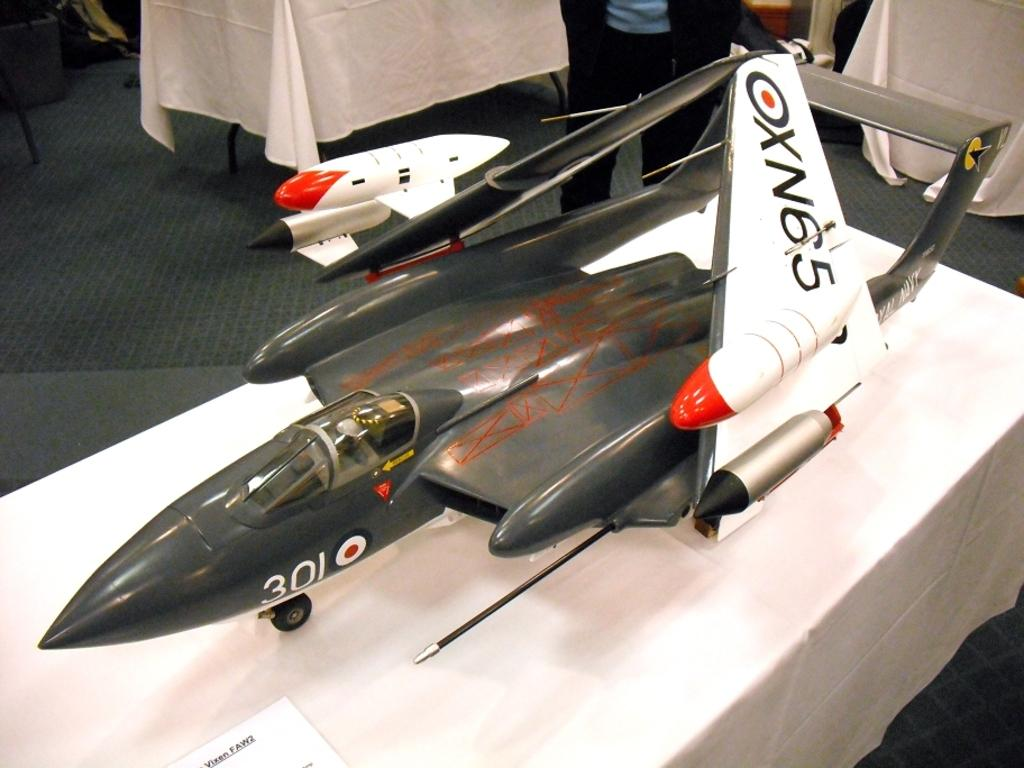<image>
Give a short and clear explanation of the subsequent image. a model airplane with the number 301 on the nosecone 